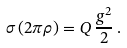<formula> <loc_0><loc_0><loc_500><loc_500>\sigma \, ( 2 \pi \rho ) = Q \, \frac { g ^ { 2 } } { 2 } \, .</formula> 